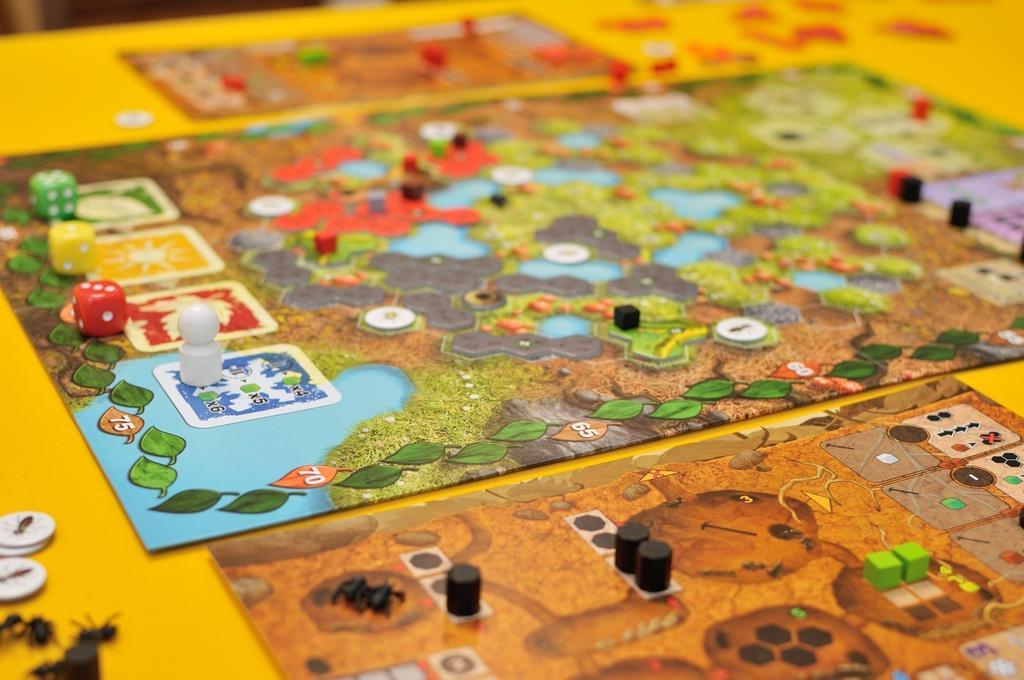Could you give a brief overview of what you see in this image? The picture consists of board games. In this picture there are dice, coins and other objects. 